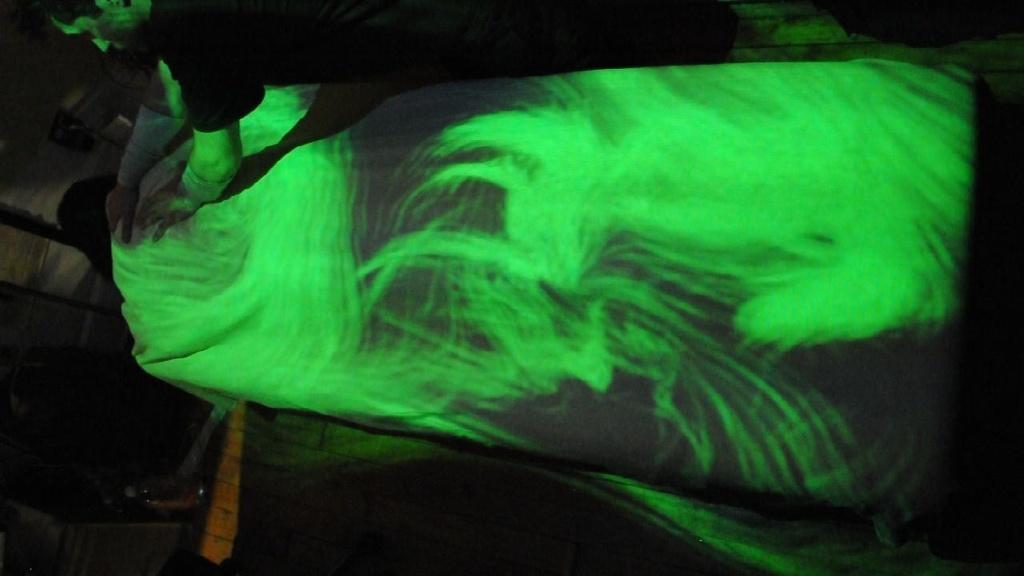What is happening between the two people in the image? In the image, one person is holding another person's back. What can be seen falling on the person being held? There is a green light falling on the person being held. How would you describe the overall lighting in the image? The image is dark. What type of muscle is being exercised by the person holding the other person's back? There is no indication in the image of which specific muscle is being exercised, as the focus is on the action of holding the back rather than the muscles involved. 